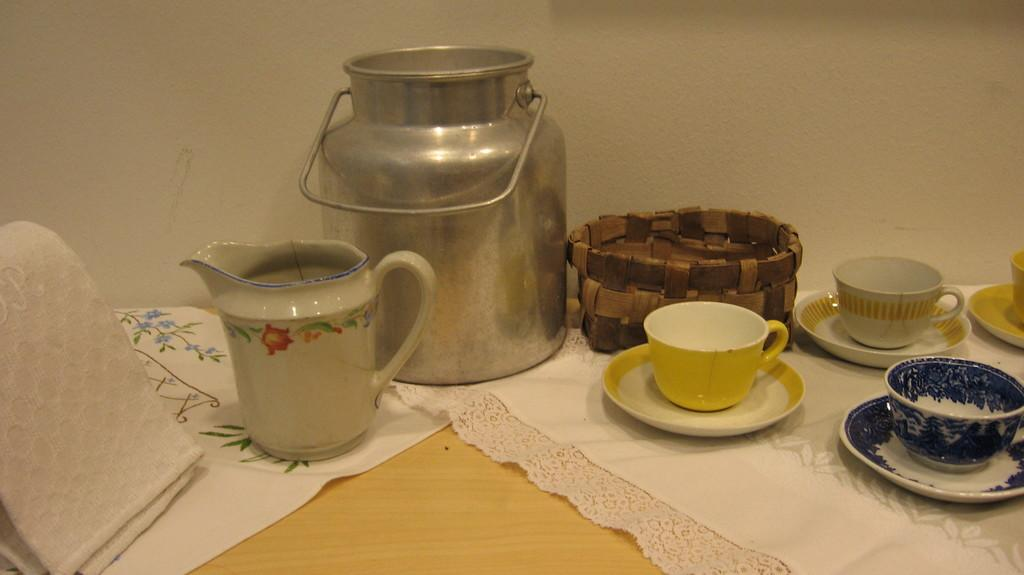What is the main piece of furniture in the image? There is a table in the image. What items are placed on the table? There are cups and saucers, as well as a small can, on the table. Can you describe the towel in the image? There is a towel on the left side of the image. What can be seen in the background of the image? There is a wall in the background of the image. What type of quartz is visible on the table in the image? There is no quartz present in the image. How does the brake function in the image? There is no brake present in the image. 